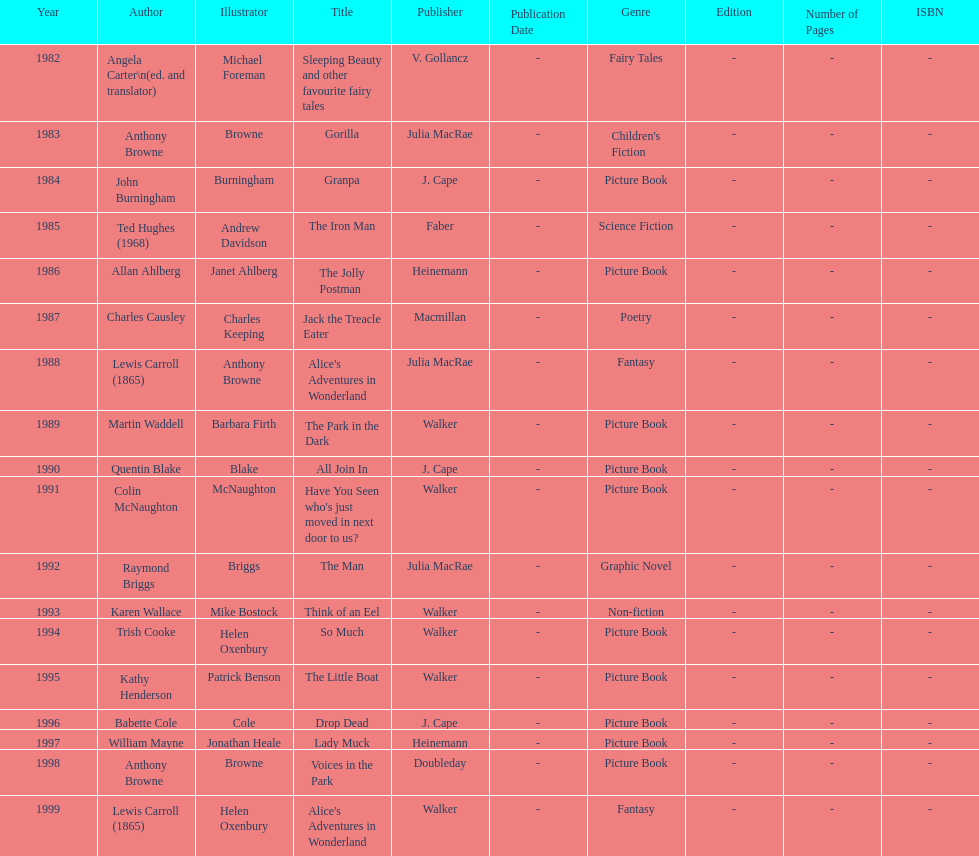Would you mind parsing the complete table? {'header': ['Year', 'Author', 'Illustrator', 'Title', 'Publisher', 'Publication Date', 'Genre', 'Edition', 'Number of Pages', 'ISBN'], 'rows': [['1982', 'Angela Carter\\n(ed. and translator)', 'Michael Foreman', 'Sleeping Beauty and other favourite fairy tales', 'V. Gollancz', '-', 'Fairy Tales', '-', '-', '-'], ['1983', 'Anthony Browne', 'Browne', 'Gorilla', 'Julia MacRae', '-', "Children's Fiction", '-', '-', '-'], ['1984', 'John Burningham', 'Burningham', 'Granpa', 'J. Cape', '-', 'Picture Book', '-', '-', '-'], ['1985', 'Ted Hughes (1968)', 'Andrew Davidson', 'The Iron Man', 'Faber', '-', 'Science Fiction', '-', '-', '-'], ['1986', 'Allan Ahlberg', 'Janet Ahlberg', 'The Jolly Postman', 'Heinemann', '-', 'Picture Book', '-', '-', '-'], ['1987', 'Charles Causley', 'Charles Keeping', 'Jack the Treacle Eater', 'Macmillan', '-', 'Poetry', '-', '-', '-'], ['1988', 'Lewis Carroll (1865)', 'Anthony Browne', "Alice's Adventures in Wonderland", 'Julia MacRae', '-', 'Fantasy', '-', '-', '-'], ['1989', 'Martin Waddell', 'Barbara Firth', 'The Park in the Dark', 'Walker', '-', 'Picture Book', '-', '-', '-'], ['1990', 'Quentin Blake', 'Blake', 'All Join In', 'J. Cape', '-', 'Picture Book', '-', '-', '-'], ['1991', 'Colin McNaughton', 'McNaughton', "Have You Seen who's just moved in next door to us?", 'Walker', '-', 'Picture Book', '-', '-', '-'], ['1992', 'Raymond Briggs', 'Briggs', 'The Man', 'Julia MacRae', '-', 'Graphic Novel', '-', '-', '-'], ['1993', 'Karen Wallace', 'Mike Bostock', 'Think of an Eel', 'Walker', '-', 'Non-fiction', '-', '-', '-'], ['1994', 'Trish Cooke', 'Helen Oxenbury', 'So Much', 'Walker', '-', 'Picture Book', '-', '-', '-'], ['1995', 'Kathy Henderson', 'Patrick Benson', 'The Little Boat', 'Walker', '-', 'Picture Book', '-', '-', '-'], ['1996', 'Babette Cole', 'Cole', 'Drop Dead', 'J. Cape', '-', 'Picture Book', '-', '-', '-'], ['1997', 'William Mayne', 'Jonathan Heale', 'Lady Muck', 'Heinemann', '-', 'Picture Book', '-', '-', '-'], ['1998', 'Anthony Browne', 'Browne', 'Voices in the Park', 'Doubleday', '-', 'Picture Book', '-', '-', '-'], ['1999', 'Lewis Carroll (1865)', 'Helen Oxenbury', "Alice's Adventures in Wonderland", 'Walker', '-', 'Fantasy', '-', '-', '-']]} What's the difference in years between angela carter's title and anthony browne's? 1. 